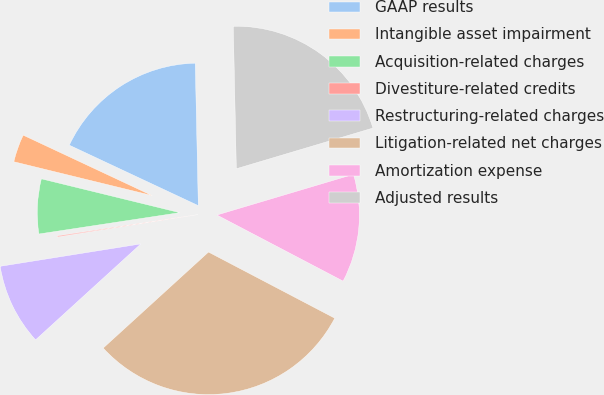Convert chart to OTSL. <chart><loc_0><loc_0><loc_500><loc_500><pie_chart><fcel>GAAP results<fcel>Intangible asset impairment<fcel>Acquisition-related charges<fcel>Divestiture-related credits<fcel>Restructuring-related charges<fcel>Litigation-related net charges<fcel>Amortization expense<fcel>Adjusted results<nl><fcel>17.68%<fcel>3.16%<fcel>6.21%<fcel>0.12%<fcel>9.25%<fcel>30.55%<fcel>12.29%<fcel>20.73%<nl></chart> 